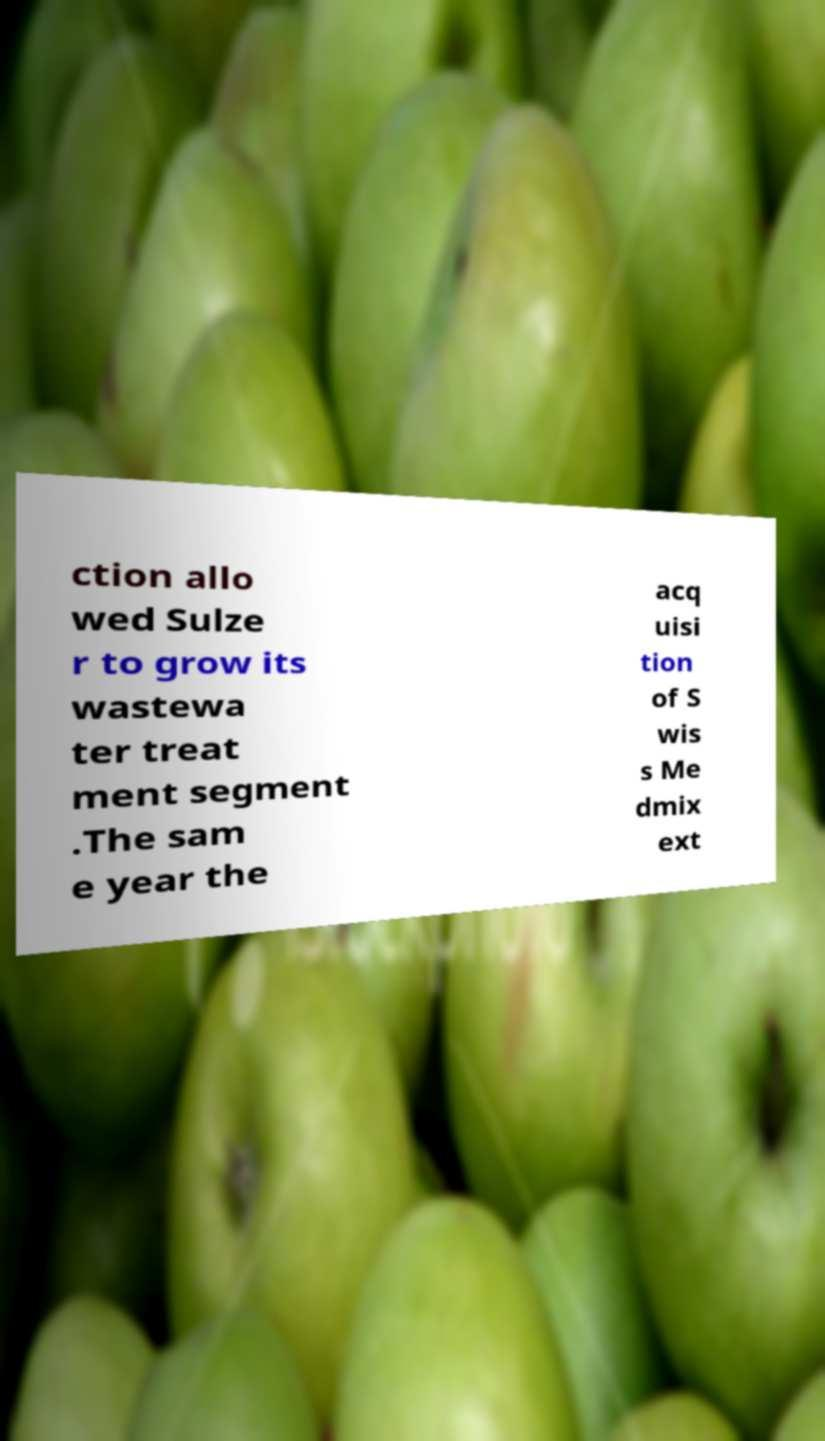Please read and relay the text visible in this image. What does it say? ction allo wed Sulze r to grow its wastewa ter treat ment segment .The sam e year the acq uisi tion of S wis s Me dmix ext 